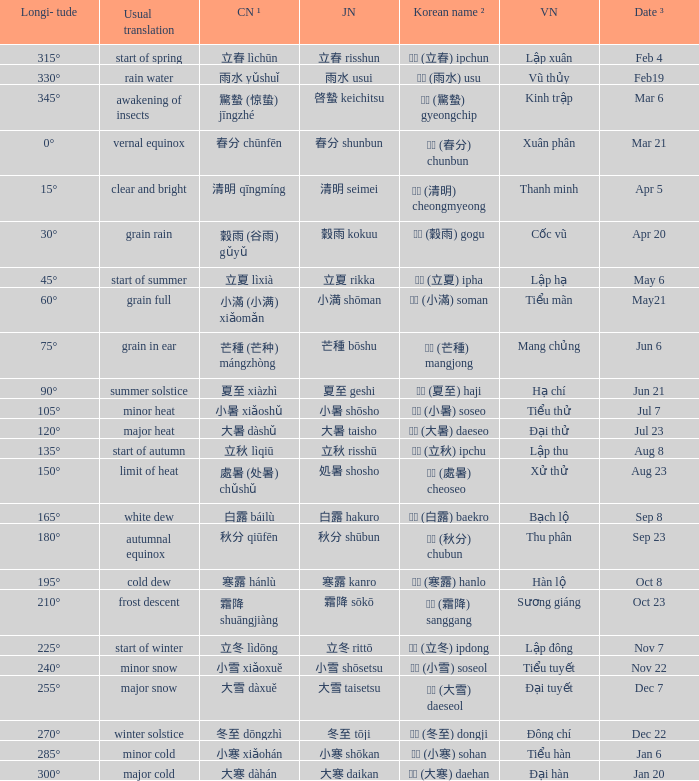WHich Usual translation is on sep 23? Autumnal equinox. 